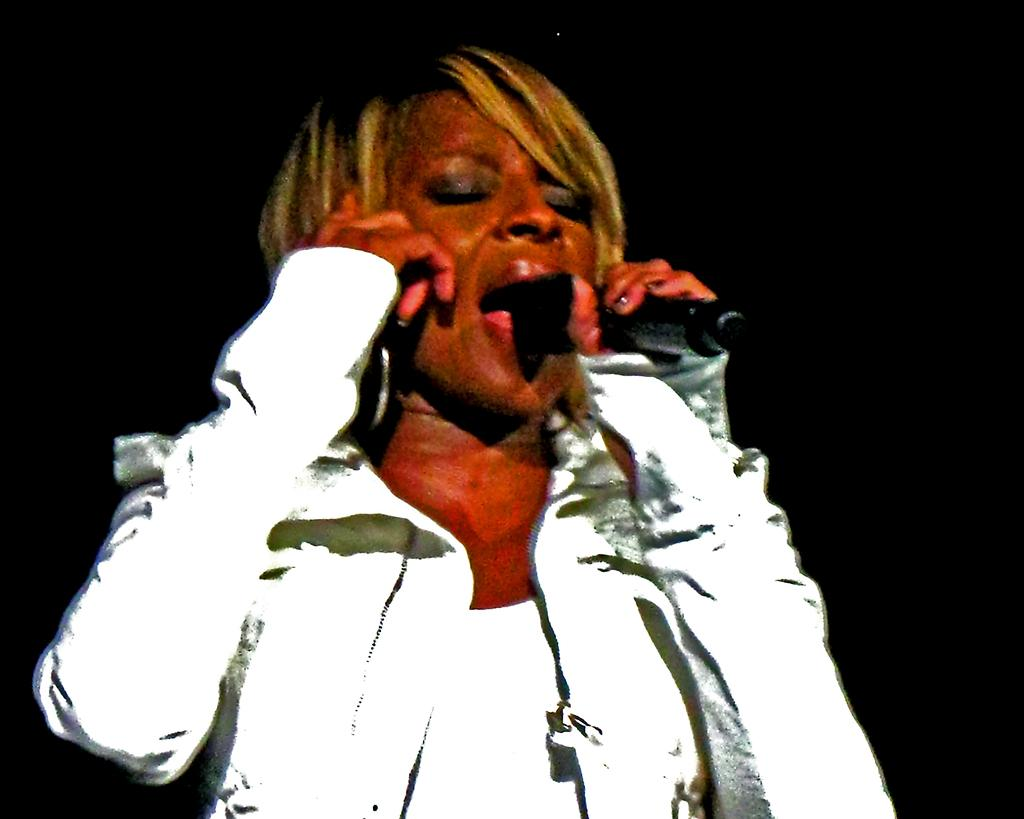What is the main subject of the image? There is a person standing in the image. What is the person holding in the image? The person is holding a microphone. Can you describe the background of the image? The background of the image is dark. What is the size of the regret in the image? There is no regret present in the image, so it cannot be measured or described. 